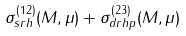<formula> <loc_0><loc_0><loc_500><loc_500>\sigma _ { s r h } ^ { ( 1 2 ) } ( M , \mu ) + \sigma _ { d r h p } ^ { ( 2 3 ) } ( M , \mu )</formula> 